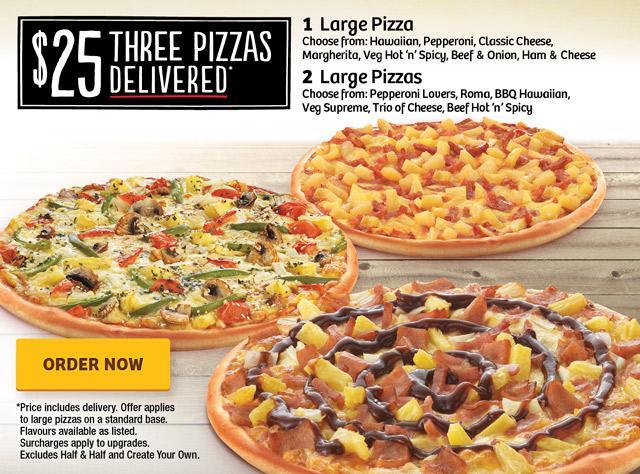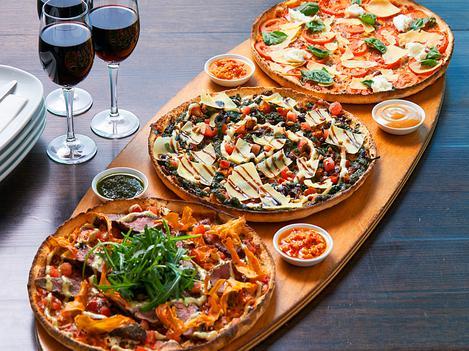The first image is the image on the left, the second image is the image on the right. Assess this claim about the two images: "There are three uncut pizzas, two are to left at the same hight and a single pizza is on the right side.". Correct or not? Answer yes or no. No. The first image is the image on the left, the second image is the image on the right. For the images shown, is this caption "At least one pizza has been sliced." true? Answer yes or no. No. 